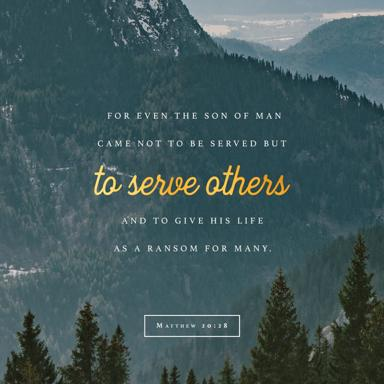How does the background image of mountains and forests relate to the text? The backdrop of mountains and forests in the image emphasizes the grandeur and the majesty of nature, paralleling the profound and selfless message in the quote. It might suggest the idea of overcoming great challenges and ascending to higher purposes, akin to the sacrifice mentioned in the text. 